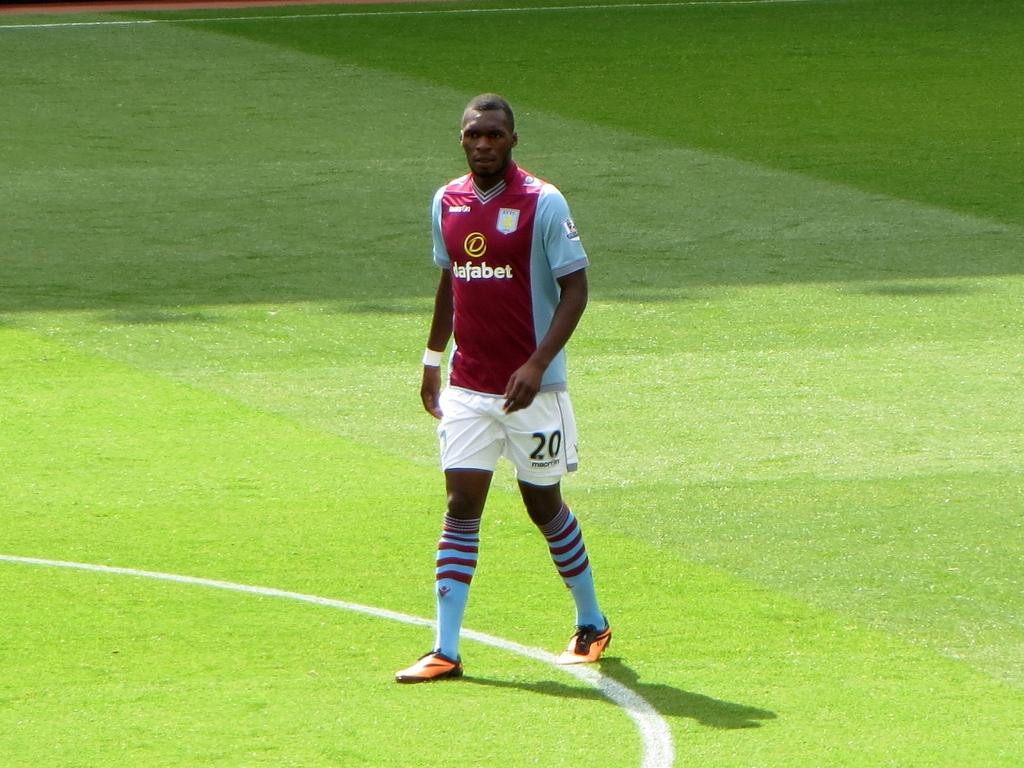<image>
Create a compact narrative representing the image presented. A player wearing a red dafabet jersey walks on the field 